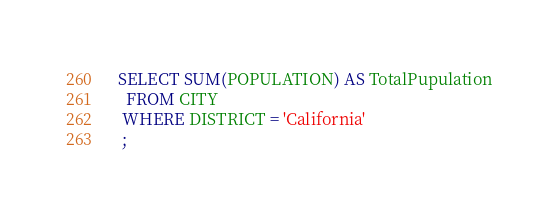<code> <loc_0><loc_0><loc_500><loc_500><_SQL_>SELECT SUM(POPULATION) AS TotalPupulation
  FROM CITY
 WHERE DISTRICT = 'California'
 ;
</code> 